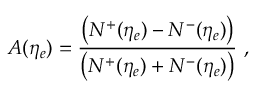Convert formula to latex. <formula><loc_0><loc_0><loc_500><loc_500>A ( \eta _ { e } ) = \frac { \left ( N ^ { + } ( \eta _ { e } ) - N ^ { - } ( \eta _ { e } ) \right ) } { \left ( N ^ { + } ( \eta _ { e } ) + N ^ { - } ( \eta _ { e } ) \right ) } \ ,</formula> 